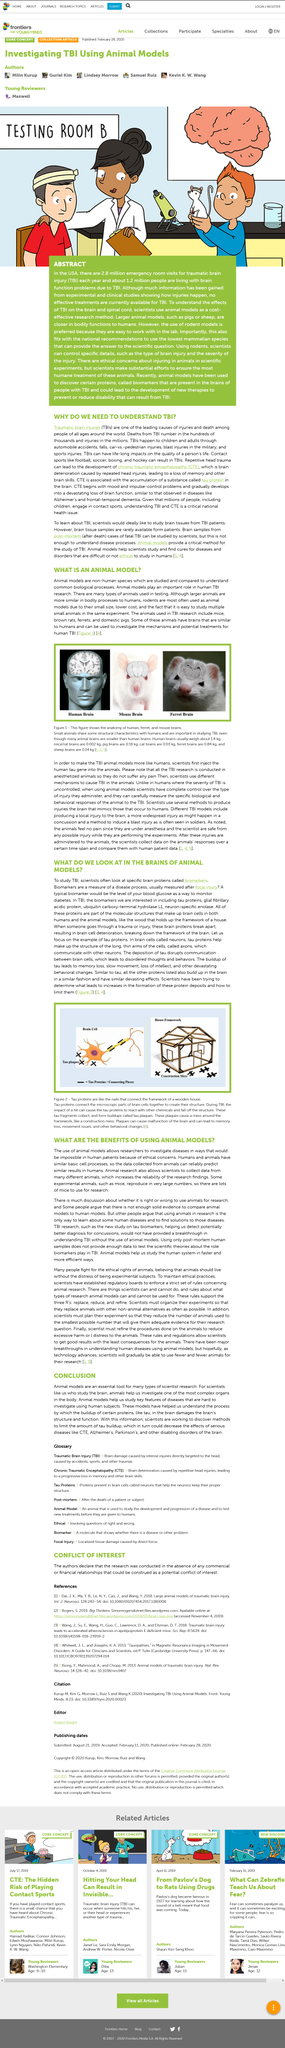Mention a couple of crucial points in this snapshot. Tau proteins are responsible for connecting the microscopic parts of brain cells to form their structure. The figure depicts the anatomy of human, ferret, and mouse brains, highlighting the similarities and differences between these organisms in terms of brain structure and organization. The scientist is searching for specific brain proteins as biomarkers to study Traumatic Brain Injury (TBI). CTE, or chronic traumatic encephalopathy, is a degenerative brain disease caused by repetitive head trauma, as declared by medical experts. Traumatic Brain Injury (TBI) is studied using animal models when human brain tissue samples are not available. 